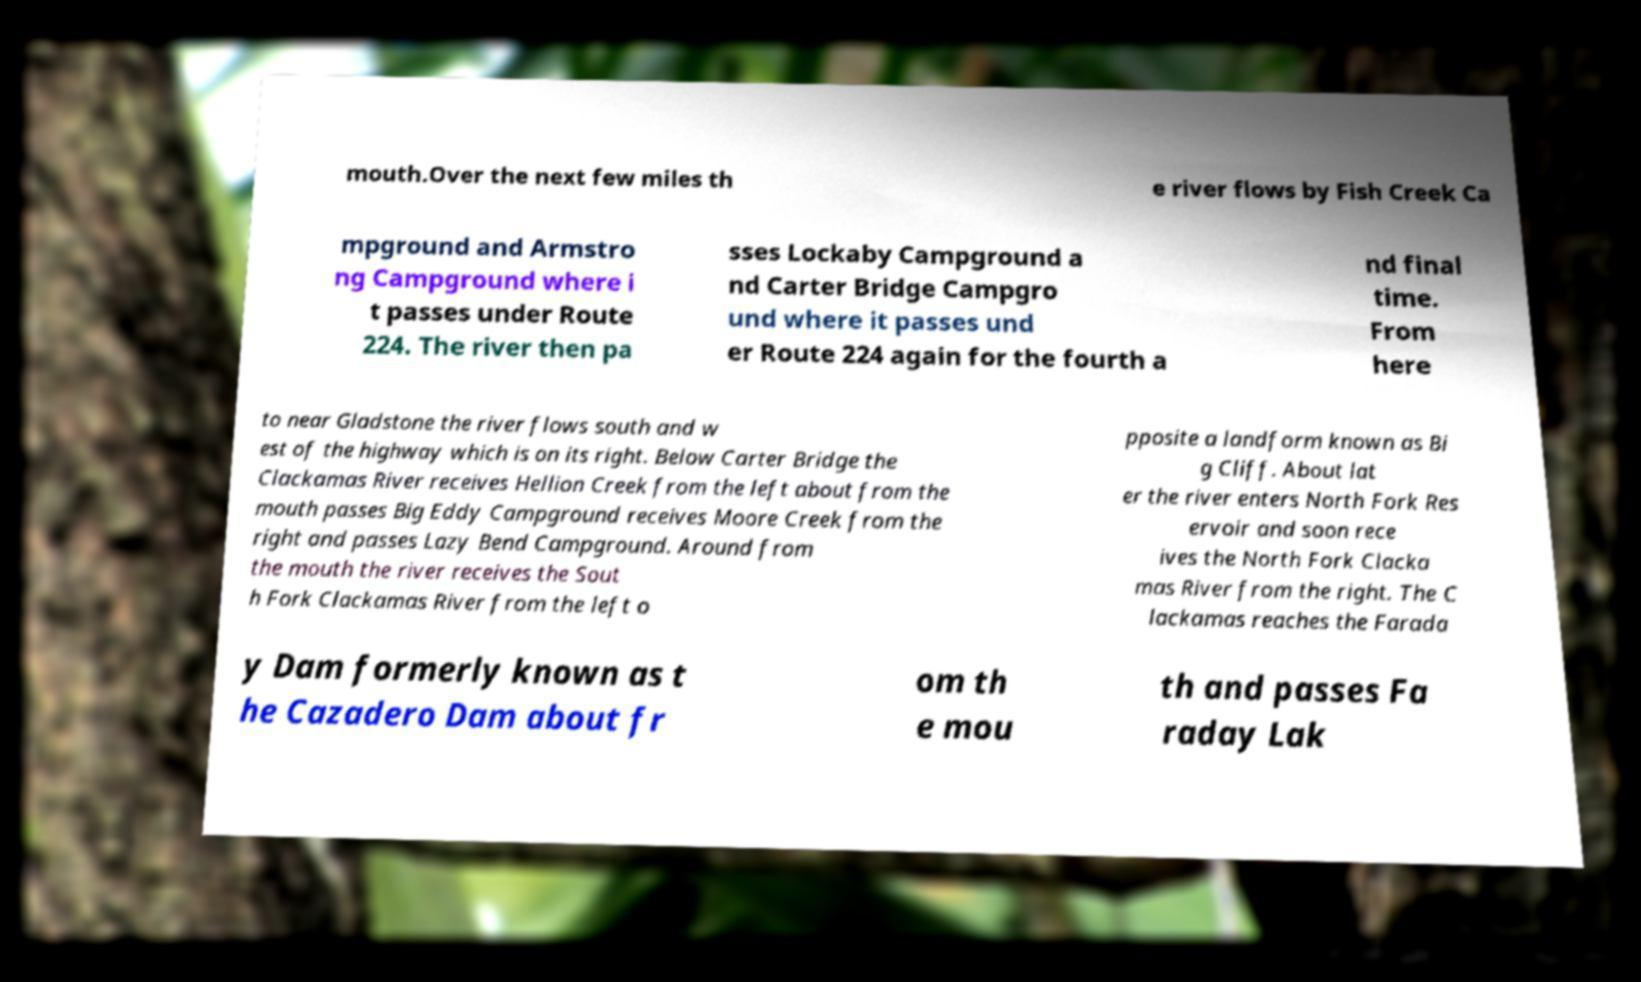Could you extract and type out the text from this image? mouth.Over the next few miles th e river flows by Fish Creek Ca mpground and Armstro ng Campground where i t passes under Route 224. The river then pa sses Lockaby Campground a nd Carter Bridge Campgro und where it passes und er Route 224 again for the fourth a nd final time. From here to near Gladstone the river flows south and w est of the highway which is on its right. Below Carter Bridge the Clackamas River receives Hellion Creek from the left about from the mouth passes Big Eddy Campground receives Moore Creek from the right and passes Lazy Bend Campground. Around from the mouth the river receives the Sout h Fork Clackamas River from the left o pposite a landform known as Bi g Cliff. About lat er the river enters North Fork Res ervoir and soon rece ives the North Fork Clacka mas River from the right. The C lackamas reaches the Farada y Dam formerly known as t he Cazadero Dam about fr om th e mou th and passes Fa raday Lak 